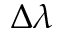<formula> <loc_0><loc_0><loc_500><loc_500>\Delta \lambda</formula> 